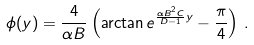Convert formula to latex. <formula><loc_0><loc_0><loc_500><loc_500>\phi ( y ) = \frac { 4 } { \alpha B } \left ( \arctan e ^ { \frac { \alpha B ^ { 2 } C } { D - 1 } y } - \frac { \pi } { 4 } \right ) \, .</formula> 